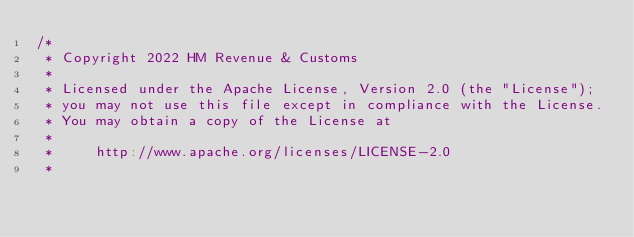Convert code to text. <code><loc_0><loc_0><loc_500><loc_500><_Scala_>/*
 * Copyright 2022 HM Revenue & Customs
 *
 * Licensed under the Apache License, Version 2.0 (the "License");
 * you may not use this file except in compliance with the License.
 * You may obtain a copy of the License at
 *
 *     http://www.apache.org/licenses/LICENSE-2.0
 *</code> 